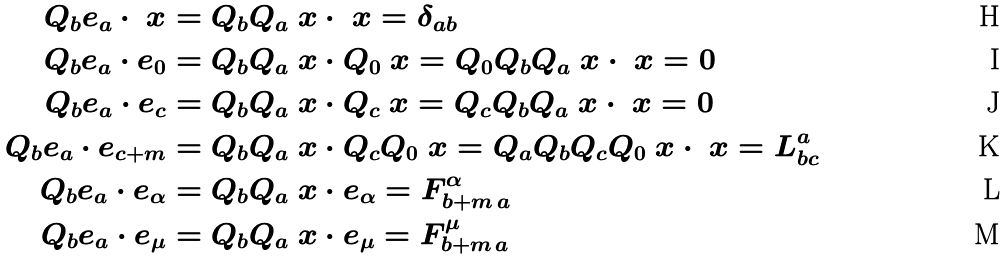<formula> <loc_0><loc_0><loc_500><loc_500>Q _ { b } e _ { a } \cdot \ x & = Q _ { b } Q _ { a } \ x \cdot \ x = \delta _ { a b } \\ Q _ { b } e _ { a } \cdot e _ { 0 } & = Q _ { b } Q _ { a } \ x \cdot Q _ { 0 } \ x = Q _ { 0 } Q _ { b } Q _ { a } \ x \cdot \ x = 0 \\ Q _ { b } e _ { a } \cdot e _ { c } & = Q _ { b } Q _ { a } \ x \cdot Q _ { c } \ x = Q _ { c } Q _ { b } Q _ { a } \ x \cdot \ x = 0 \\ Q _ { b } e _ { a } \cdot e _ { c + m } & = Q _ { b } Q _ { a } \ x \cdot Q _ { c } Q _ { 0 } \ x = Q _ { a } Q _ { b } Q _ { c } Q _ { 0 } \ x \cdot \ x = L ^ { a } _ { b c } \\ Q _ { b } e _ { a } \cdot e _ { \alpha } & = Q _ { b } Q _ { a } \ x \cdot e _ { \alpha } = F ^ { \alpha } _ { b + m \, a } \\ Q _ { b } e _ { a } \cdot e _ { \mu } & = Q _ { b } Q _ { a } \ x \cdot e _ { \mu } = F ^ { \mu } _ { b + m \, a }</formula> 